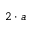Convert formula to latex. <formula><loc_0><loc_0><loc_500><loc_500>2 \cdot a</formula> 